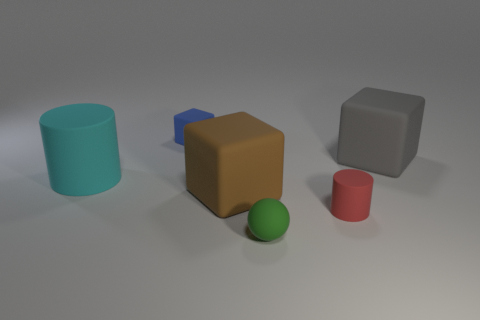Subtract all blue blocks. How many blocks are left? 2 Subtract 1 cubes. How many cubes are left? 2 Add 1 green matte objects. How many objects exist? 7 Subtract all cylinders. How many objects are left? 4 Subtract all red blocks. Subtract all blue balls. How many blocks are left? 3 Subtract all large gray metallic balls. Subtract all big gray matte objects. How many objects are left? 5 Add 6 tiny blue rubber cubes. How many tiny blue rubber cubes are left? 7 Add 6 cyan rubber cylinders. How many cyan rubber cylinders exist? 7 Subtract 1 red cylinders. How many objects are left? 5 